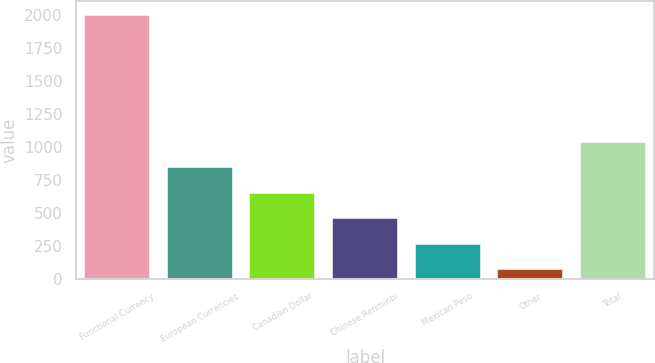Convert chart to OTSL. <chart><loc_0><loc_0><loc_500><loc_500><bar_chart><fcel>Functional Currency<fcel>European Currencies<fcel>Canadian Dollar<fcel>Chinese Renminbi<fcel>Mexican Peso<fcel>Other<fcel>Total<nl><fcel>2007<fcel>845.22<fcel>651.59<fcel>457.96<fcel>264.33<fcel>70.7<fcel>1038.85<nl></chart> 